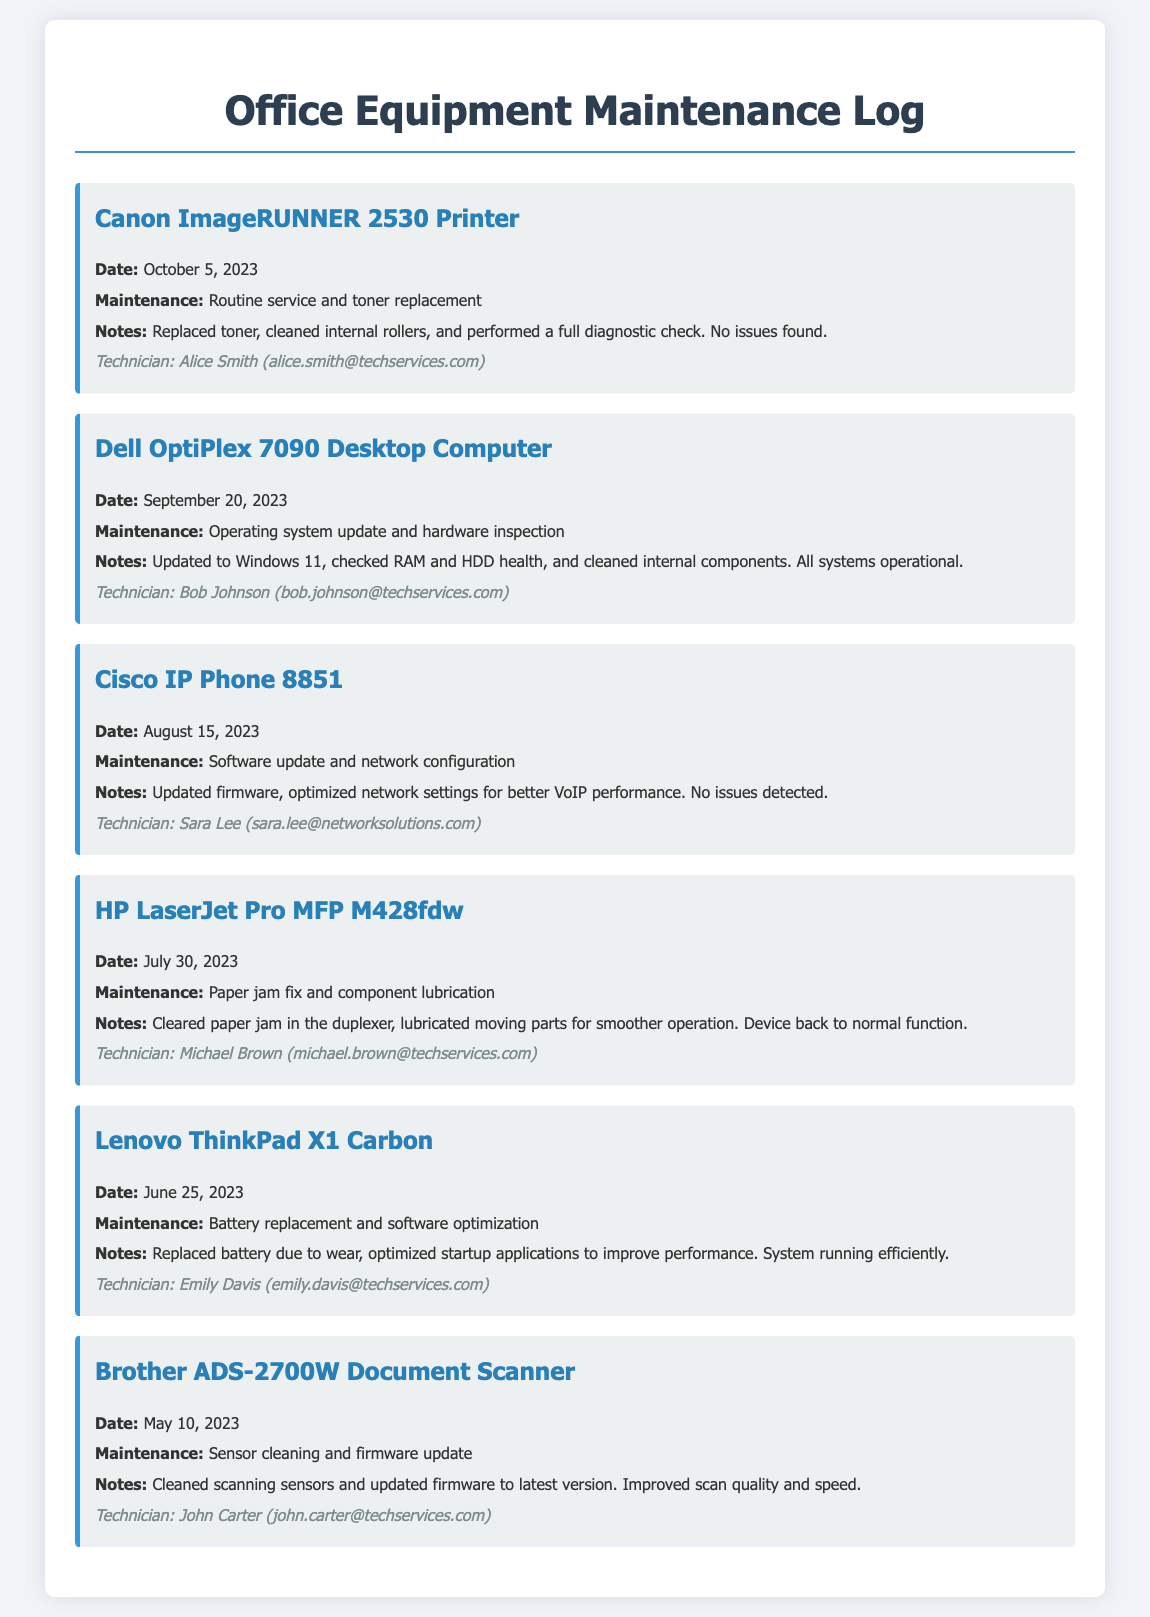What is the maintenance date for the Canon ImageRUNNER 2530 Printer? The maintenance date is explicitly stated in the log as "October 5, 2023."
Answer: October 5, 2023 What type of maintenance was performed on the Dell OptiPlex 7090 Desktop Computer? The log indicates that the maintenance performed was an "Operating system update and hardware inspection."
Answer: Operating system update and hardware inspection Who was the technician for the Cisco IP Phone 8851 maintenance? The technician's name is found in the log, which states "Technician: Sara Lee."
Answer: Sara Lee How many devices were maintained in May 2023? The document lists only one maintenance entry for May 2023 related to the Brother ADS-2700W Document Scanner.
Answer: 1 What issue was resolved for the HP LaserJet Pro MFP M428fdw? The log entry states that a "paper jam" was fixed during maintenance.
Answer: Paper jam How many log entries mention cleaning as part of the maintenance? Two log entries refer to cleaning actions: one for the Canon ImageRUNNER 2530 Printer and another for the Brother ADS-2700W Document Scanner.
Answer: 2 What was the nature of the maintenance for the Lenovo ThinkPad X1 Carbon? The entry specifies "Battery replacement and software optimization" as the nature of the maintenance performed.
Answer: Battery replacement and software optimization What was replaced during the maintenance of the Lenovo ThinkPad X1 Carbon? The log entry specifically mentions that the "battery" was replaced due to wear.
Answer: Battery What firmware update was performed on the Cisco IP Phone 8851? The maintenance log indicates that a "software update" and "firmware" update was completed.
Answer: Firmware update 